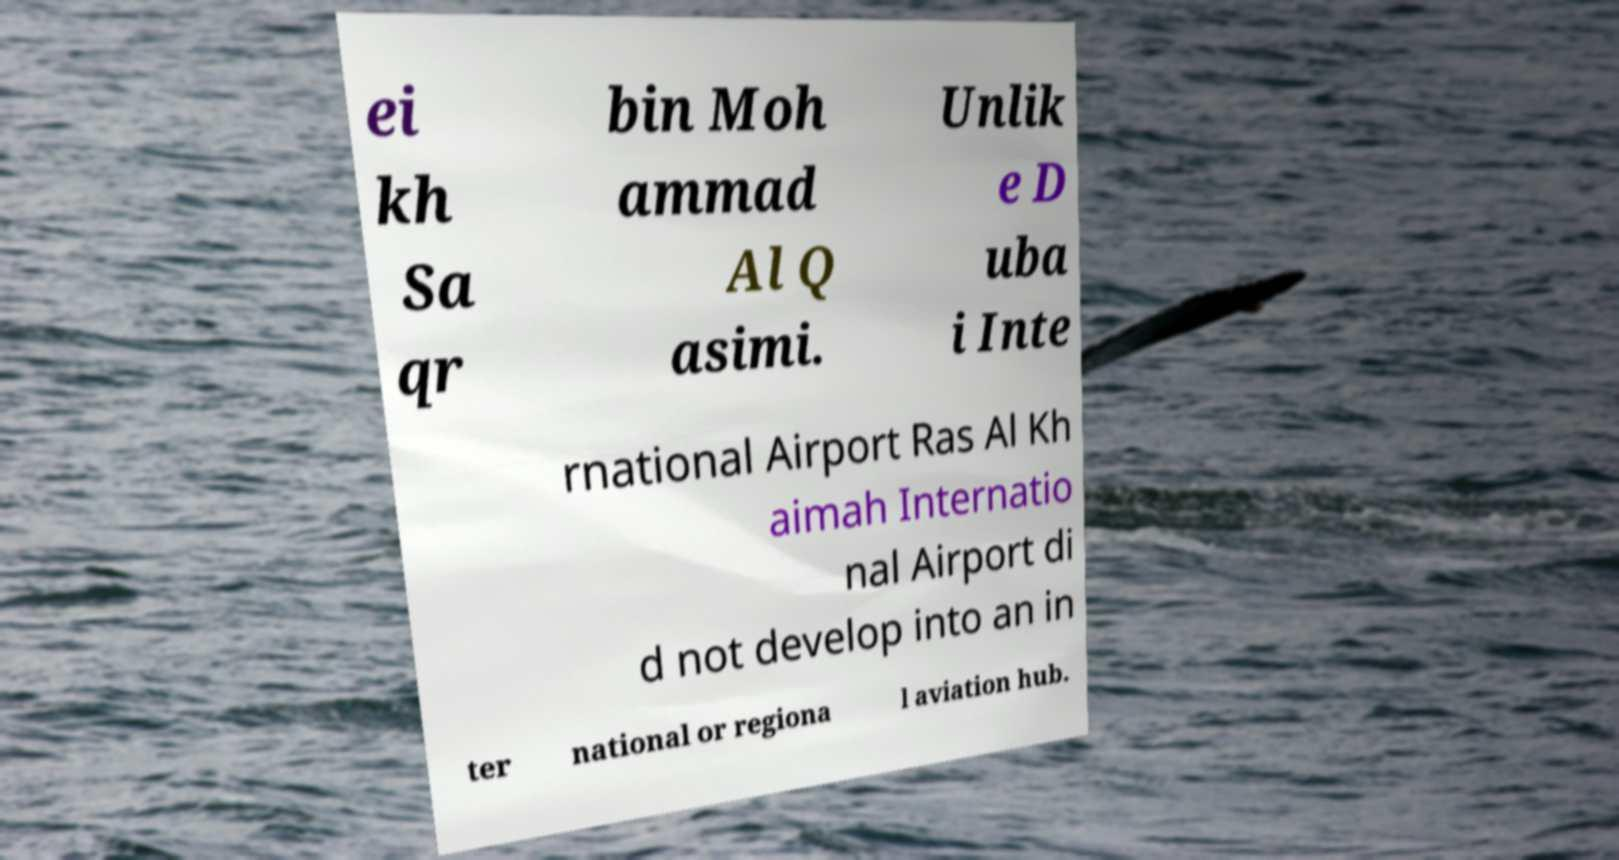What messages or text are displayed in this image? I need them in a readable, typed format. ei kh Sa qr bin Moh ammad Al Q asimi. Unlik e D uba i Inte rnational Airport Ras Al Kh aimah Internatio nal Airport di d not develop into an in ter national or regiona l aviation hub. 